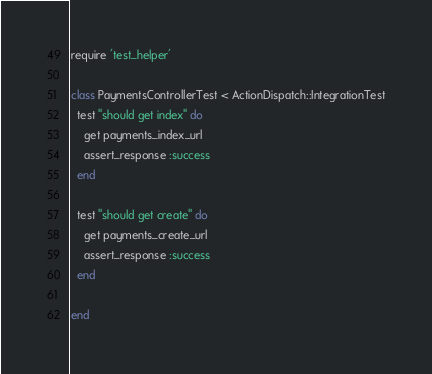Convert code to text. <code><loc_0><loc_0><loc_500><loc_500><_Ruby_>require 'test_helper'

class PaymentsControllerTest < ActionDispatch::IntegrationTest
  test "should get index" do
    get payments_index_url
    assert_response :success
  end

  test "should get create" do
    get payments_create_url
    assert_response :success
  end

end
</code> 